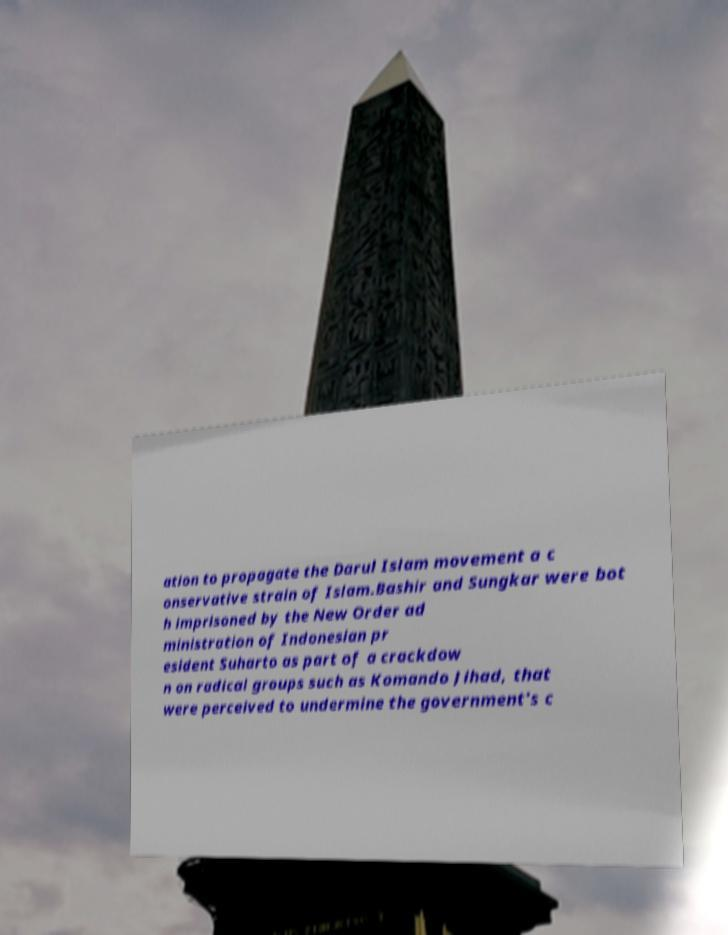Could you extract and type out the text from this image? ation to propagate the Darul Islam movement a c onservative strain of Islam.Bashir and Sungkar were bot h imprisoned by the New Order ad ministration of Indonesian pr esident Suharto as part of a crackdow n on radical groups such as Komando Jihad, that were perceived to undermine the government's c 